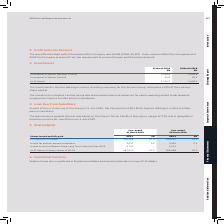According to Sophos Group's financial document, What does the investment in Sophos Holdings Limited comprise? 100% of the ordinary share capital.. The document states: "a holding company for the Sophos Group, comprises 100% of the ordinary share capital...." Also, What does the investment in Sophos Limited comprise? share-based payment expenses for equity awards granted to participants employed by Sophos Limited and its subsidiaries.. The document states: "The investment in Sophos Limited comprises share-based payment expenses for equity awards granted to participants employed by Sophos Limited and its s..." Also, What are the different investments listed in the table? The document shows two values: Investment in Sophos Holdings Limited and Investment in Sophos Limited. From the document: "Investment in Sophos Holdings Limited 1,035.8 1,035.8 Investment in Sophos Limited 94.8 63.3..." Additionally, In which year was the amount at the end of the fiscal year larger? According to the financial document, 2019. The relevant text states: "31 March 2019 $M 31 March 2018 $M..." Also, can you calculate: What was the change in the amount of Investment in Sophos Limited in 2019 from 2018? Based on the calculation: 94.8-63.3, the result is 31.5 (in millions). This is based on the information: "Investment in Sophos Limited 94.8 63.3 Investment in Sophos Limited 94.8 63.3..." The key data points involved are: 63.3, 94.8. Also, can you calculate: What was the percentage change in the amount of Investment in Sophos Limited in 2019 from 2018? To answer this question, I need to perform calculations using the financial data. The calculation is: (94.8-63.3)/63.3, which equals 49.76 (percentage). This is based on the information: "Investment in Sophos Limited 94.8 63.3 Investment in Sophos Limited 94.8 63.3..." The key data points involved are: 63.3, 94.8. 